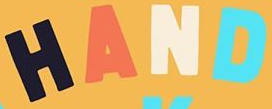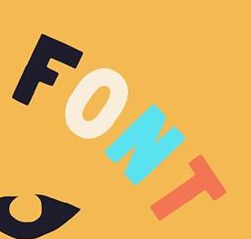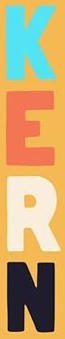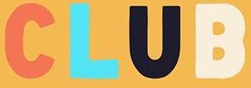Transcribe the words shown in these images in order, separated by a semicolon. HAND; FONT; KERN; CLUB 